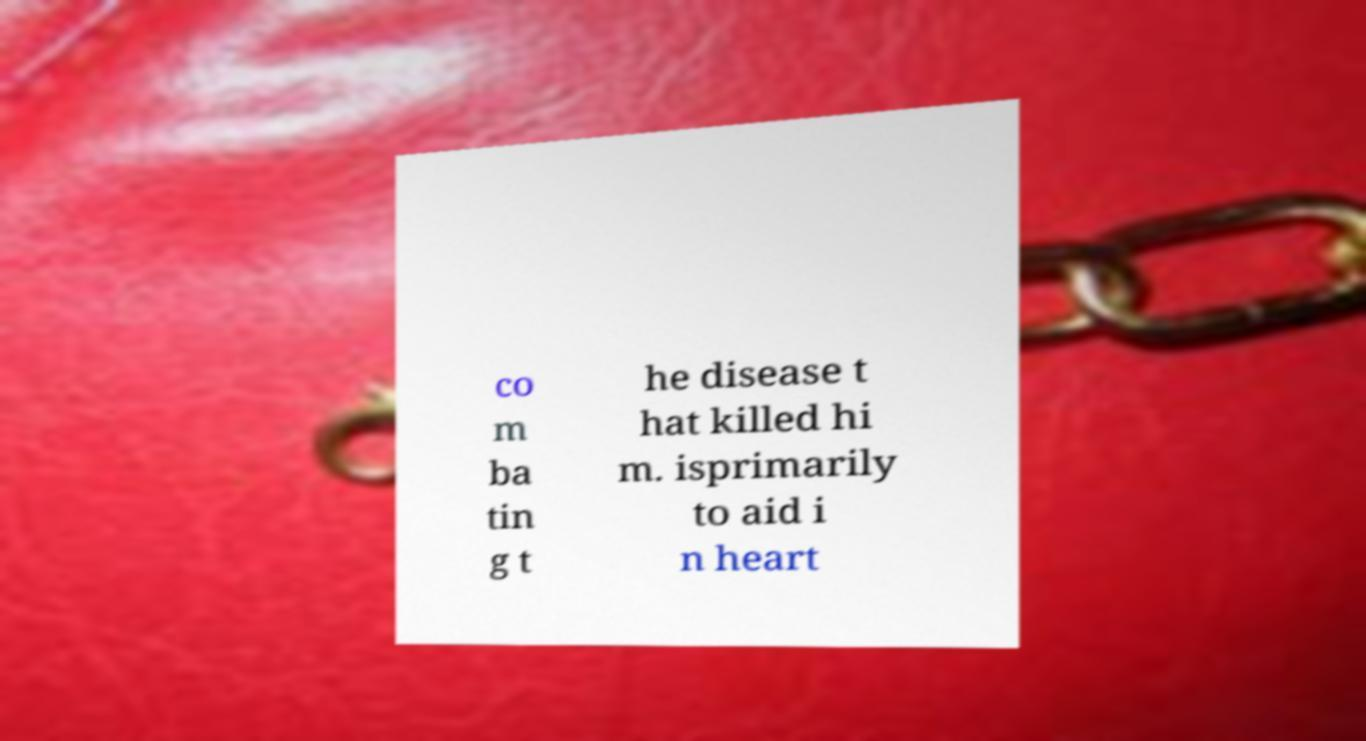Can you read and provide the text displayed in the image?This photo seems to have some interesting text. Can you extract and type it out for me? co m ba tin g t he disease t hat killed hi m. isprimarily to aid i n heart 